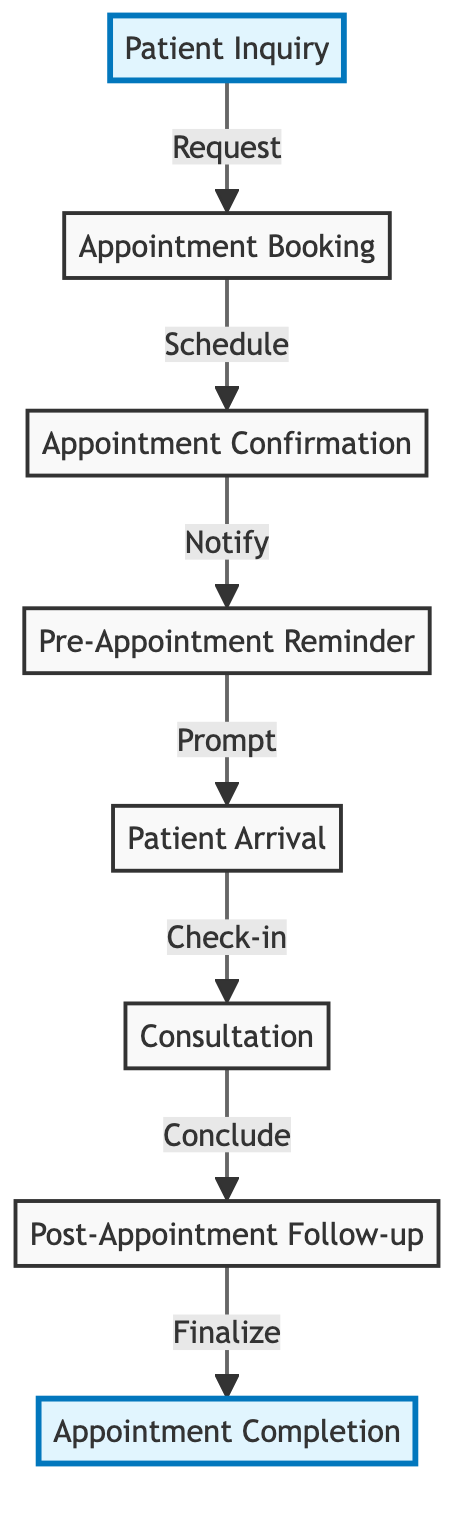What is the first step in the appointment scheduling timeline? The first step in the timeline is "Patient Inquiry," which is the starting point for all following interactions.
Answer: Patient Inquiry Which node indicates the confirmation of the appointment? The node that indicates the confirmation of the appointment is "Appointment Confirmation". This is the third step in the flow.
Answer: Appointment Confirmation How many nodes are present in the diagram? The diagram contains a total of 8 nodes, representing distinct stages of the appointment process.
Answer: 8 What is the last step that occurs after the Post-Appointment Follow-up? The last step that occurs after the Post-Appointment Follow-up is "Appointment Completion," which concludes the sequence of interactions.
Answer: Appointment Completion How many edges are there connecting the nodes? There are 7 edges connecting the nodes, indicating the flow from one step to the next in the appointment scheduling process.
Answer: 7 What action is associated with the transition from "Patient Arrival" to "Consultation"? The action associated with the transition from "Patient Arrival" to "Consultation" is "Check-in," which is the procedure that occurs as the patient arrives.
Answer: Check-in Which stage follows "Pre-Appointment Reminder"? The stage that follows "Pre-Appointment Reminder" is "Patient Arrival," marking the patient's arrival at the clinic for their scheduled appointment.
Answer: Patient Arrival What is the relationship between "Consultation" and "Post-Appointment Follow-up"? The relationship between "Consultation" and "Post-Appointment Follow-up" is a sequential flow where the consultation leads directly to a follow-up to address any post-appointment needs.
Answer: Consultation leads to Post-Appointment Follow-up What is the second node in the timeline? The second node in the timeline is "Appointment Booking," which follows the initial inquiry made by the patient.
Answer: Appointment Booking 